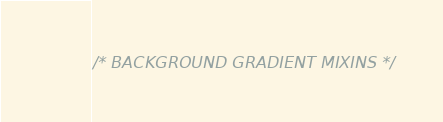Convert code to text. <code><loc_0><loc_0><loc_500><loc_500><_CSS_>/* BACKGROUND GRADIENT MIXINS */
</code> 